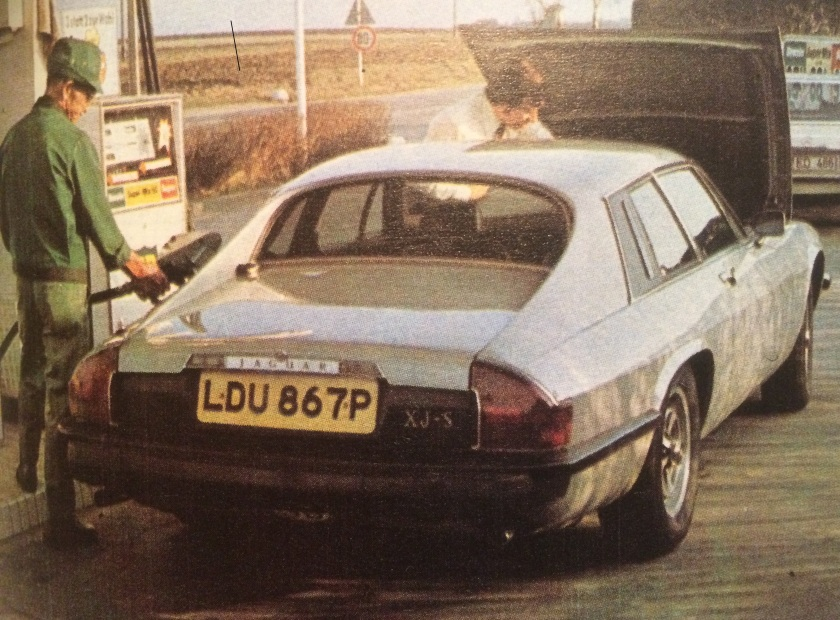Describe a possible realistic scenario depicted in the image. In this realistic scenario, the driver is on a road trip and stops by a gas station to refuel. While the uniformed attendant fills the tank, the driver opens the boot to ensure their luggage is secure and retrieves a map to check the next part of their route. This scene is set in the late 1970s when personalized service at gas stations was common, reflecting a time when long drives through the countryside were more leisurely and required ample preparation and care.  Could this image depict a family's weekend getaway preparations? Yes, it's quite possible. The image could capture a moment where the family is preparing for a weekend getaway. The driver might be getting the final refueling done and ensuring everything they need is packed efficiently in the boot. This moment of preparation at the gas station marks the calm before the joy and excitement of a short vacation trip, characteristic of family travels in the 1970s. 